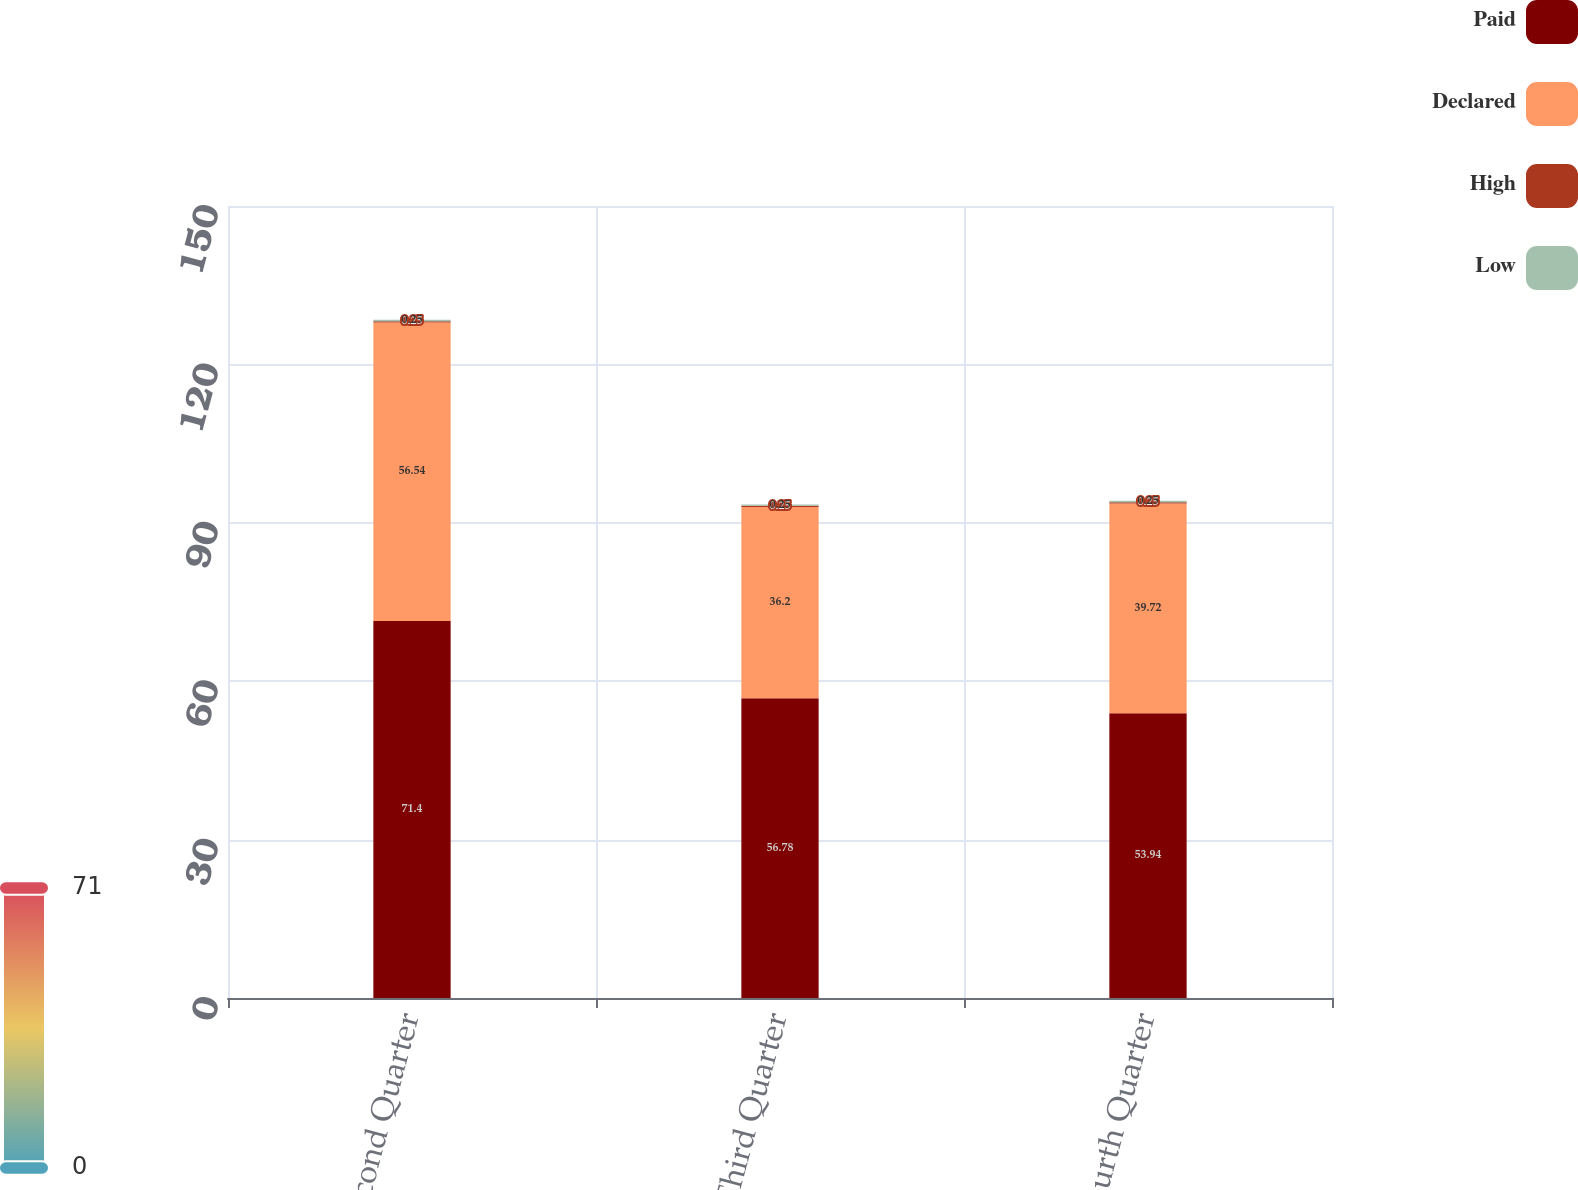Convert chart. <chart><loc_0><loc_0><loc_500><loc_500><stacked_bar_chart><ecel><fcel>Second Quarter<fcel>Third Quarter<fcel>Fourth Quarter<nl><fcel>Paid<fcel>71.4<fcel>56.78<fcel>53.94<nl><fcel>Declared<fcel>56.54<fcel>36.2<fcel>39.72<nl><fcel>High<fcel>0.25<fcel>0.25<fcel>0.25<nl><fcel>Low<fcel>0.25<fcel>0.25<fcel>0.25<nl></chart> 